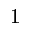<formula> <loc_0><loc_0><loc_500><loc_500>^ { 1 }</formula> 